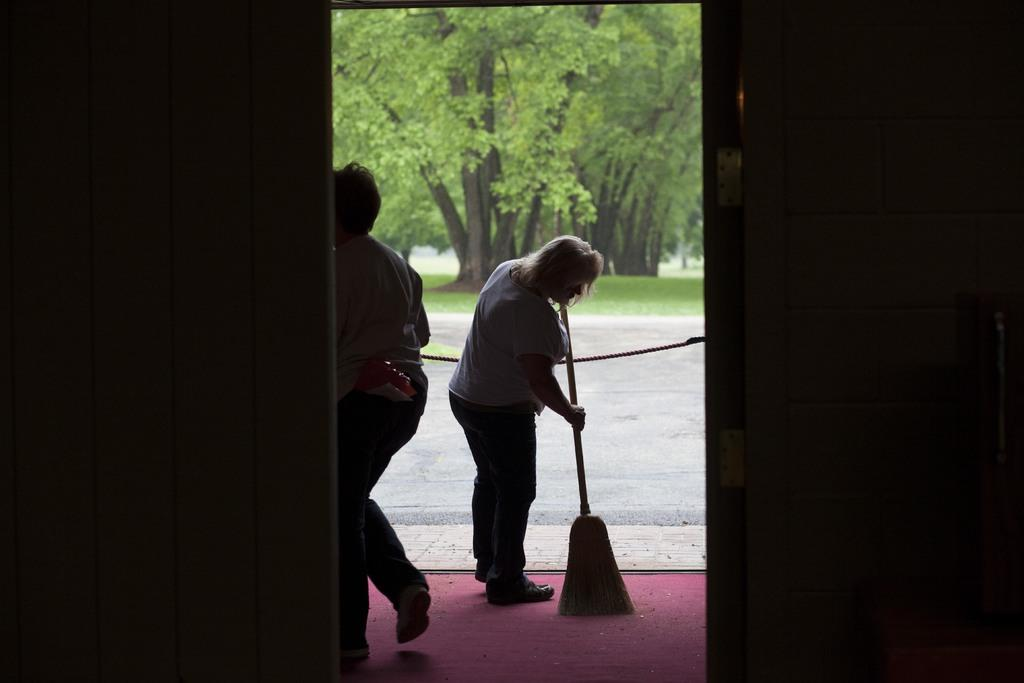What is the woman in the image doing? The woman is brooming the floor with a broom stick. Can you describe the action of the person in the image? The person is walking in the image. Where is the person located in the image? The person is on the left side of the image. What can be seen in the background of the image? There are trees in the background of the image. What type of environment are the trees located in? The trees are on a grassland. What type of cap is the woman wearing in the image? There is no cap visible in the image; the woman is using a broom stick to sweep the floor. 